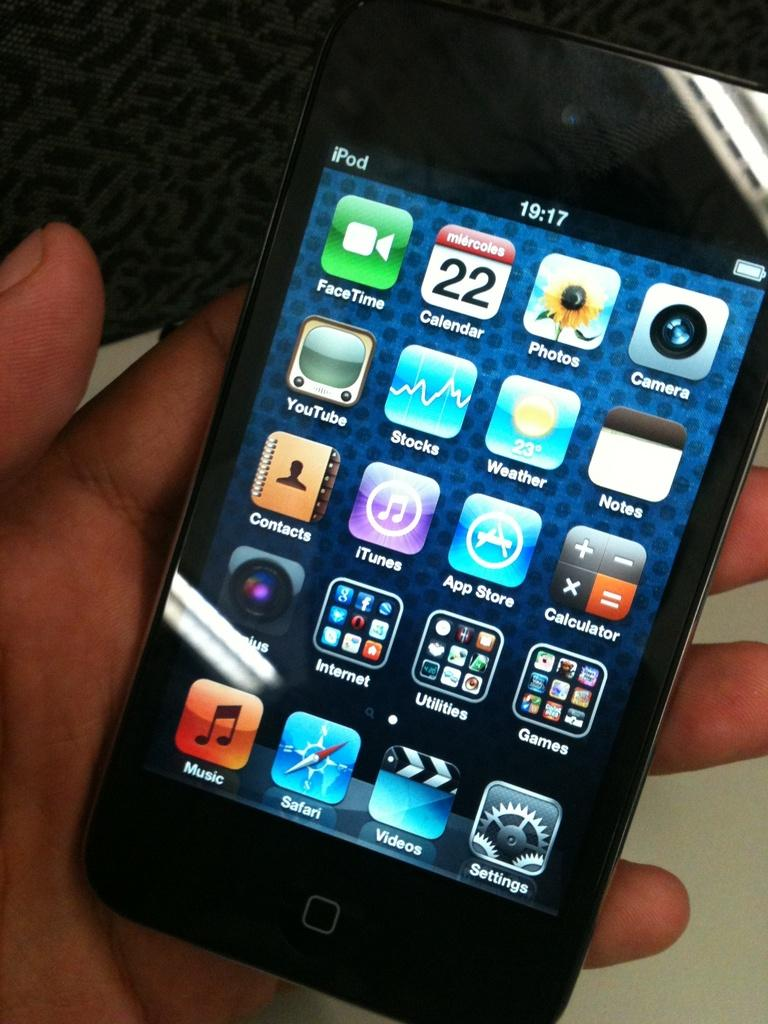<image>
Create a compact narrative representing the image presented. A person is holding an Apple iPod in their hand. 